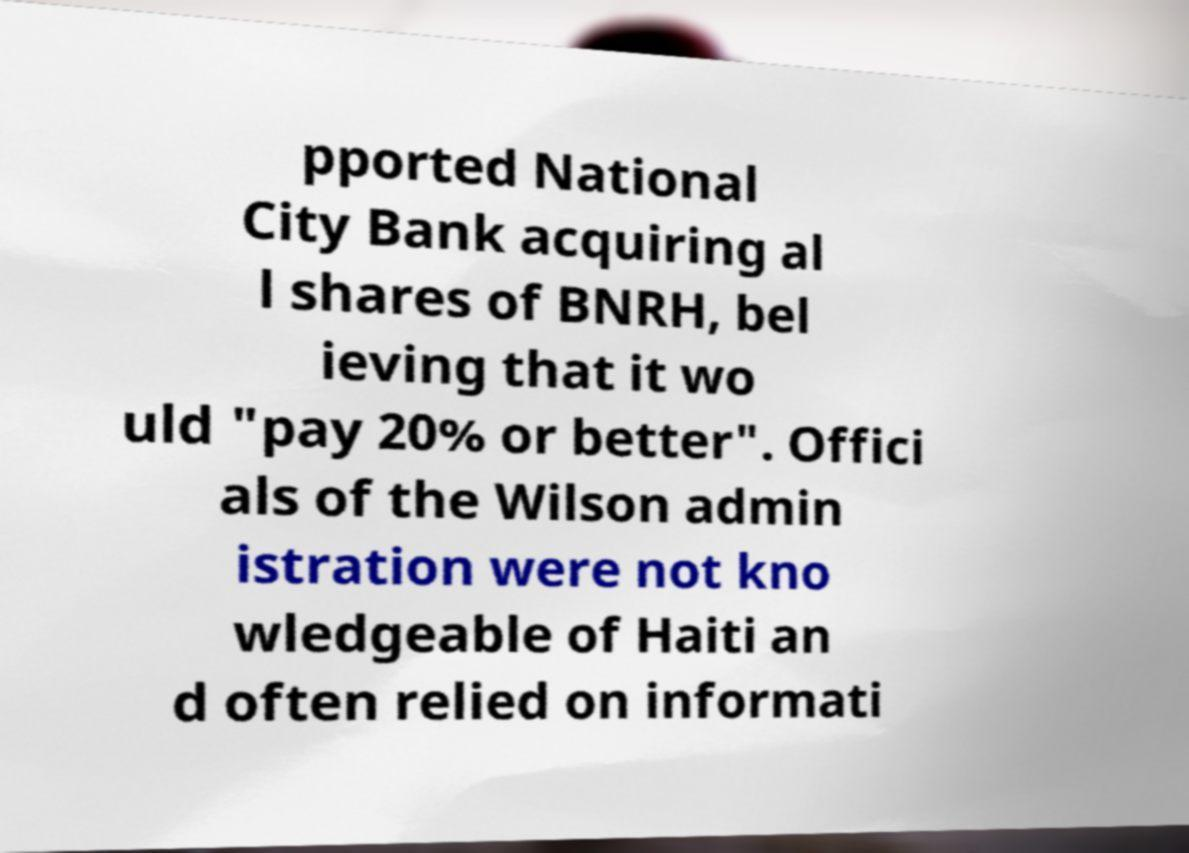Please identify and transcribe the text found in this image. pported National City Bank acquiring al l shares of BNRH, bel ieving that it wo uld "pay 20% or better". Offici als of the Wilson admin istration were not kno wledgeable of Haiti an d often relied on informati 